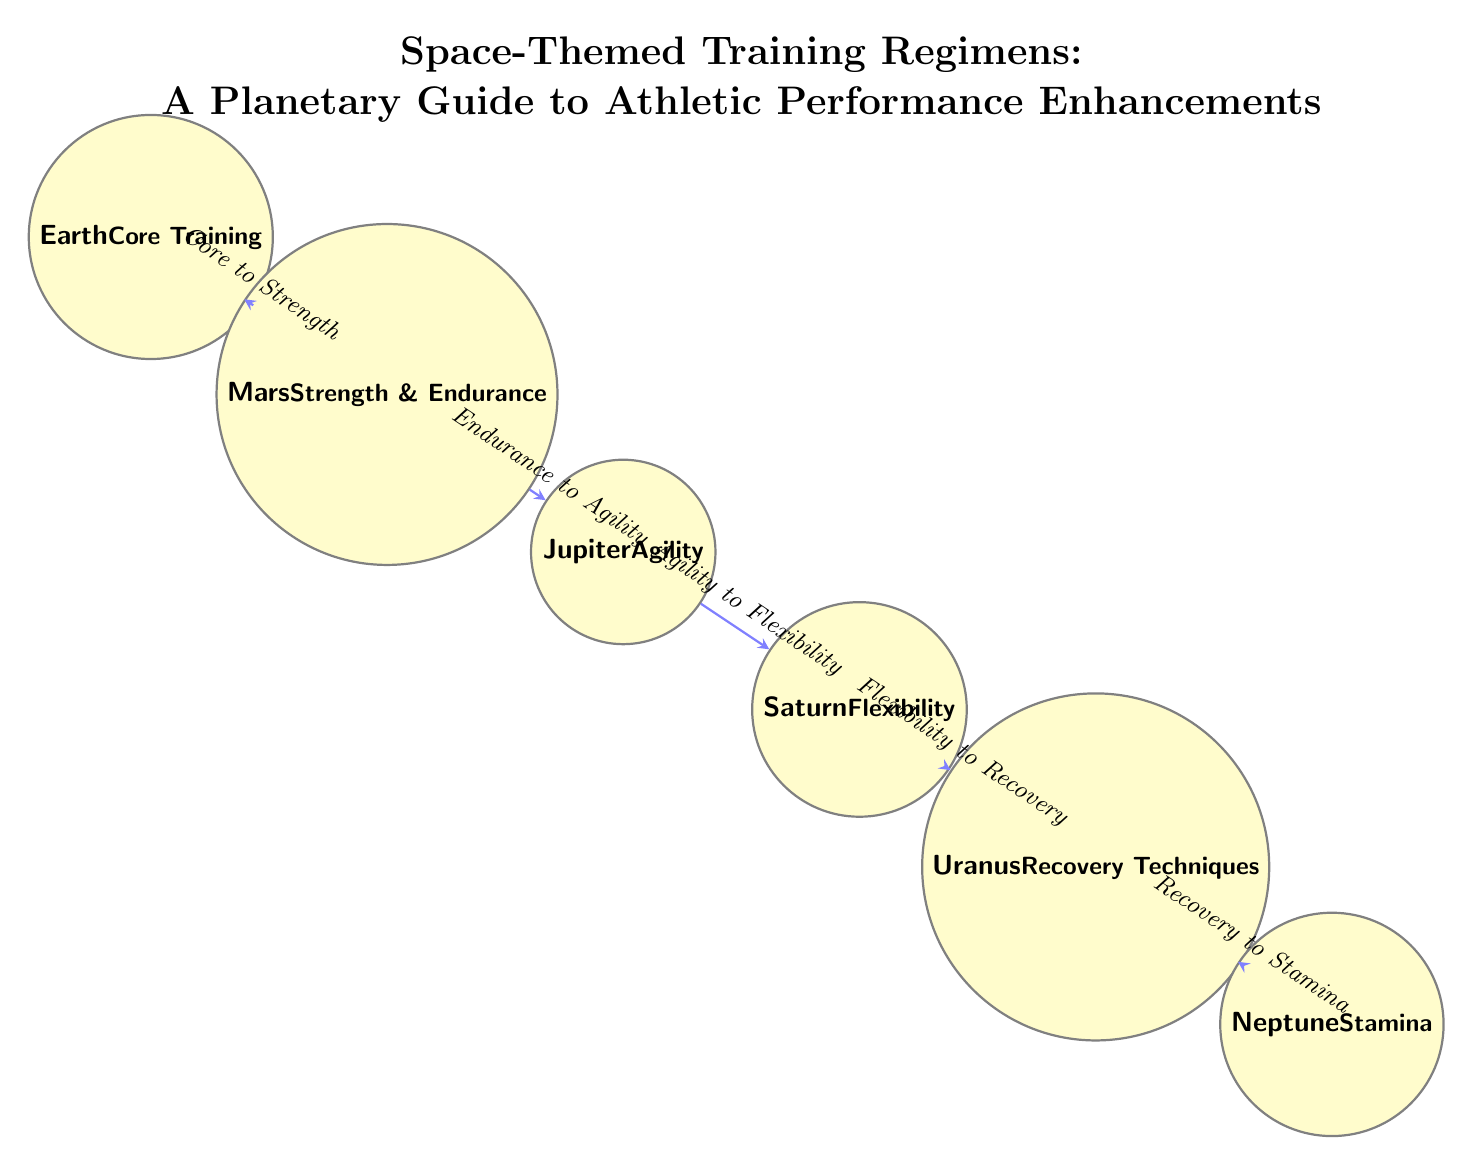What is the central training regimen shown in the diagram? The central training regimen is represented by the node labeled "Earth," which indicates it is the starting point for the training path.
Answer: Earth How many nodes are in the diagram? By counting the circular nodes displayed in the diagram, there are a total of six nodes representing different training regimens.
Answer: 6 What is the connection between Mars and Jupiter? The connection between Mars and Jupiter is labeled "Endurance to Agility," indicating a progression from strength and endurance training to agility training.
Answer: Endurance to Agility Which planet is associated with recovery techniques? The planet associated with recovery techniques is Uranus, as labeled in the diagram.
Answer: Uranus What is the last training regimen in the flow? The last training regimen in the flow is represented by Neptune, which is the final node in the sequence and is associated with stamina.
Answer: Neptune What is the relationship from Saturn to Uranus? The relationship from Saturn to Uranus is labeled "Flexibility to Recovery," indicating a transition in focus from flexibility training to recovery techniques.
Answer: Flexibility to Recovery What do the arrows in the diagram represent? The arrows in the diagram represent directional connections or relationships between the training regimens, indicating the flow and progression of training.
Answer: Directional connections Explain the overall progression of training regimens from Earth to Neptune. The progression starts at Earth with core training, then moves to Mars for strength and endurance, followed by Jupiter focusing on agility. Next is Saturn emphasizing flexibility, then Uranus for recovery techniques, and finally ending at Neptune for stamina, showcasing a comprehensive athletic training path.
Answer: Core to Stamina 